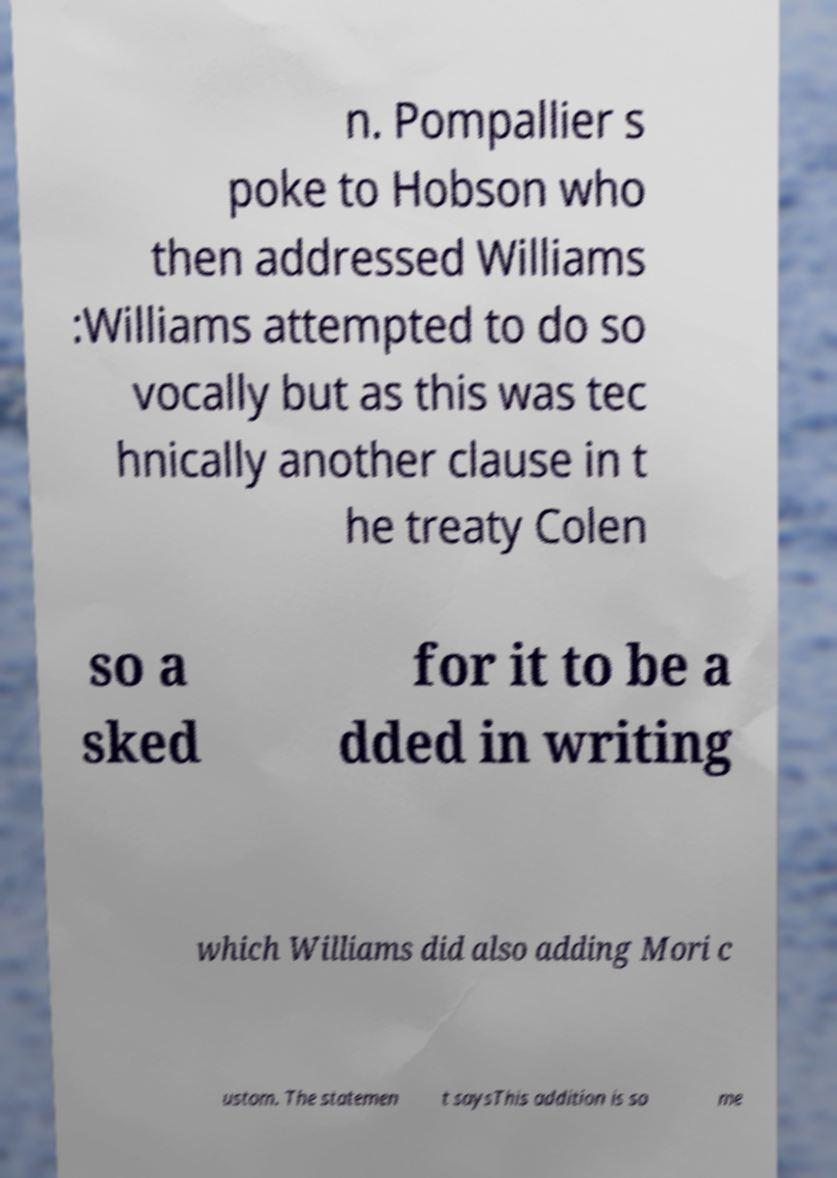Please identify and transcribe the text found in this image. n. Pompallier s poke to Hobson who then addressed Williams :Williams attempted to do so vocally but as this was tec hnically another clause in t he treaty Colen so a sked for it to be a dded in writing which Williams did also adding Mori c ustom. The statemen t saysThis addition is so me 